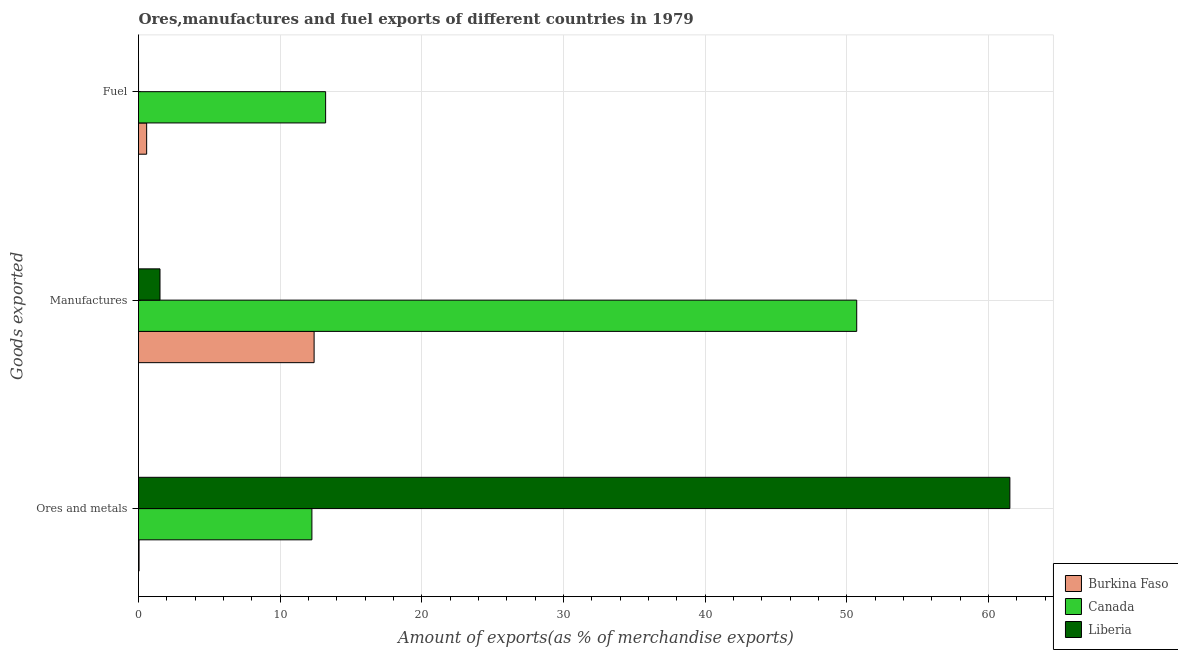How many different coloured bars are there?
Make the answer very short. 3. How many groups of bars are there?
Your answer should be very brief. 3. Are the number of bars per tick equal to the number of legend labels?
Provide a succinct answer. Yes. Are the number of bars on each tick of the Y-axis equal?
Offer a very short reply. Yes. How many bars are there on the 3rd tick from the top?
Your answer should be compact. 3. How many bars are there on the 1st tick from the bottom?
Your response must be concise. 3. What is the label of the 1st group of bars from the top?
Offer a very short reply. Fuel. What is the percentage of manufactures exports in Burkina Faso?
Offer a terse response. 12.4. Across all countries, what is the maximum percentage of fuel exports?
Make the answer very short. 13.21. Across all countries, what is the minimum percentage of fuel exports?
Keep it short and to the point. 0. In which country was the percentage of ores and metals exports minimum?
Your answer should be compact. Burkina Faso. What is the total percentage of ores and metals exports in the graph?
Give a very brief answer. 73.79. What is the difference between the percentage of ores and metals exports in Canada and that in Liberia?
Provide a short and direct response. -49.27. What is the difference between the percentage of manufactures exports in Burkina Faso and the percentage of fuel exports in Liberia?
Offer a very short reply. 12.4. What is the average percentage of manufactures exports per country?
Your response must be concise. 21.54. What is the difference between the percentage of manufactures exports and percentage of fuel exports in Canada?
Ensure brevity in your answer.  37.49. What is the ratio of the percentage of fuel exports in Liberia to that in Burkina Faso?
Make the answer very short. 0. Is the difference between the percentage of manufactures exports in Burkina Faso and Canada greater than the difference between the percentage of ores and metals exports in Burkina Faso and Canada?
Offer a terse response. No. What is the difference between the highest and the second highest percentage of ores and metals exports?
Your answer should be compact. 49.27. What is the difference between the highest and the lowest percentage of ores and metals exports?
Keep it short and to the point. 61.48. Is the sum of the percentage of ores and metals exports in Burkina Faso and Liberia greater than the maximum percentage of fuel exports across all countries?
Provide a succinct answer. Yes. What does the 3rd bar from the bottom in Fuel represents?
Offer a terse response. Liberia. How many bars are there?
Provide a succinct answer. 9. Are all the bars in the graph horizontal?
Provide a succinct answer. Yes. How many countries are there in the graph?
Your answer should be compact. 3. What is the difference between two consecutive major ticks on the X-axis?
Keep it short and to the point. 10. Does the graph contain grids?
Provide a short and direct response. Yes. Where does the legend appear in the graph?
Provide a short and direct response. Bottom right. How many legend labels are there?
Offer a terse response. 3. What is the title of the graph?
Your answer should be compact. Ores,manufactures and fuel exports of different countries in 1979. Does "Central Europe" appear as one of the legend labels in the graph?
Provide a short and direct response. No. What is the label or title of the X-axis?
Offer a terse response. Amount of exports(as % of merchandise exports). What is the label or title of the Y-axis?
Make the answer very short. Goods exported. What is the Amount of exports(as % of merchandise exports) of Burkina Faso in Ores and metals?
Your response must be concise. 0.04. What is the Amount of exports(as % of merchandise exports) in Canada in Ores and metals?
Keep it short and to the point. 12.24. What is the Amount of exports(as % of merchandise exports) of Liberia in Ores and metals?
Ensure brevity in your answer.  61.51. What is the Amount of exports(as % of merchandise exports) in Burkina Faso in Manufactures?
Ensure brevity in your answer.  12.4. What is the Amount of exports(as % of merchandise exports) in Canada in Manufactures?
Your response must be concise. 50.7. What is the Amount of exports(as % of merchandise exports) of Liberia in Manufactures?
Ensure brevity in your answer.  1.52. What is the Amount of exports(as % of merchandise exports) in Burkina Faso in Fuel?
Offer a very short reply. 0.58. What is the Amount of exports(as % of merchandise exports) in Canada in Fuel?
Provide a short and direct response. 13.21. What is the Amount of exports(as % of merchandise exports) of Liberia in Fuel?
Ensure brevity in your answer.  0. Across all Goods exported, what is the maximum Amount of exports(as % of merchandise exports) in Burkina Faso?
Make the answer very short. 12.4. Across all Goods exported, what is the maximum Amount of exports(as % of merchandise exports) of Canada?
Keep it short and to the point. 50.7. Across all Goods exported, what is the maximum Amount of exports(as % of merchandise exports) of Liberia?
Provide a short and direct response. 61.51. Across all Goods exported, what is the minimum Amount of exports(as % of merchandise exports) of Burkina Faso?
Give a very brief answer. 0.04. Across all Goods exported, what is the minimum Amount of exports(as % of merchandise exports) in Canada?
Provide a short and direct response. 12.24. Across all Goods exported, what is the minimum Amount of exports(as % of merchandise exports) of Liberia?
Your answer should be very brief. 0. What is the total Amount of exports(as % of merchandise exports) in Burkina Faso in the graph?
Your answer should be compact. 13.01. What is the total Amount of exports(as % of merchandise exports) in Canada in the graph?
Provide a succinct answer. 76.15. What is the total Amount of exports(as % of merchandise exports) of Liberia in the graph?
Provide a succinct answer. 63.03. What is the difference between the Amount of exports(as % of merchandise exports) in Burkina Faso in Ores and metals and that in Manufactures?
Ensure brevity in your answer.  -12.36. What is the difference between the Amount of exports(as % of merchandise exports) of Canada in Ores and metals and that in Manufactures?
Make the answer very short. -38.46. What is the difference between the Amount of exports(as % of merchandise exports) in Liberia in Ores and metals and that in Manufactures?
Keep it short and to the point. 60. What is the difference between the Amount of exports(as % of merchandise exports) in Burkina Faso in Ores and metals and that in Fuel?
Ensure brevity in your answer.  -0.54. What is the difference between the Amount of exports(as % of merchandise exports) in Canada in Ores and metals and that in Fuel?
Ensure brevity in your answer.  -0.97. What is the difference between the Amount of exports(as % of merchandise exports) of Liberia in Ores and metals and that in Fuel?
Provide a short and direct response. 61.51. What is the difference between the Amount of exports(as % of merchandise exports) in Burkina Faso in Manufactures and that in Fuel?
Your response must be concise. 11.82. What is the difference between the Amount of exports(as % of merchandise exports) of Canada in Manufactures and that in Fuel?
Offer a terse response. 37.49. What is the difference between the Amount of exports(as % of merchandise exports) in Liberia in Manufactures and that in Fuel?
Ensure brevity in your answer.  1.52. What is the difference between the Amount of exports(as % of merchandise exports) of Burkina Faso in Ores and metals and the Amount of exports(as % of merchandise exports) of Canada in Manufactures?
Provide a succinct answer. -50.66. What is the difference between the Amount of exports(as % of merchandise exports) of Burkina Faso in Ores and metals and the Amount of exports(as % of merchandise exports) of Liberia in Manufactures?
Provide a succinct answer. -1.48. What is the difference between the Amount of exports(as % of merchandise exports) in Canada in Ores and metals and the Amount of exports(as % of merchandise exports) in Liberia in Manufactures?
Your answer should be very brief. 10.72. What is the difference between the Amount of exports(as % of merchandise exports) in Burkina Faso in Ores and metals and the Amount of exports(as % of merchandise exports) in Canada in Fuel?
Make the answer very short. -13.17. What is the difference between the Amount of exports(as % of merchandise exports) in Burkina Faso in Ores and metals and the Amount of exports(as % of merchandise exports) in Liberia in Fuel?
Offer a terse response. 0.04. What is the difference between the Amount of exports(as % of merchandise exports) of Canada in Ores and metals and the Amount of exports(as % of merchandise exports) of Liberia in Fuel?
Provide a short and direct response. 12.24. What is the difference between the Amount of exports(as % of merchandise exports) of Burkina Faso in Manufactures and the Amount of exports(as % of merchandise exports) of Canada in Fuel?
Give a very brief answer. -0.81. What is the difference between the Amount of exports(as % of merchandise exports) of Burkina Faso in Manufactures and the Amount of exports(as % of merchandise exports) of Liberia in Fuel?
Provide a succinct answer. 12.4. What is the difference between the Amount of exports(as % of merchandise exports) in Canada in Manufactures and the Amount of exports(as % of merchandise exports) in Liberia in Fuel?
Your answer should be compact. 50.7. What is the average Amount of exports(as % of merchandise exports) in Burkina Faso per Goods exported?
Provide a short and direct response. 4.34. What is the average Amount of exports(as % of merchandise exports) in Canada per Goods exported?
Your answer should be very brief. 25.38. What is the average Amount of exports(as % of merchandise exports) of Liberia per Goods exported?
Give a very brief answer. 21.01. What is the difference between the Amount of exports(as % of merchandise exports) in Burkina Faso and Amount of exports(as % of merchandise exports) in Canada in Ores and metals?
Your answer should be very brief. -12.2. What is the difference between the Amount of exports(as % of merchandise exports) in Burkina Faso and Amount of exports(as % of merchandise exports) in Liberia in Ores and metals?
Your answer should be compact. -61.48. What is the difference between the Amount of exports(as % of merchandise exports) of Canada and Amount of exports(as % of merchandise exports) of Liberia in Ores and metals?
Offer a terse response. -49.27. What is the difference between the Amount of exports(as % of merchandise exports) in Burkina Faso and Amount of exports(as % of merchandise exports) in Canada in Manufactures?
Give a very brief answer. -38.31. What is the difference between the Amount of exports(as % of merchandise exports) in Burkina Faso and Amount of exports(as % of merchandise exports) in Liberia in Manufactures?
Make the answer very short. 10.88. What is the difference between the Amount of exports(as % of merchandise exports) in Canada and Amount of exports(as % of merchandise exports) in Liberia in Manufactures?
Your answer should be very brief. 49.19. What is the difference between the Amount of exports(as % of merchandise exports) of Burkina Faso and Amount of exports(as % of merchandise exports) of Canada in Fuel?
Provide a succinct answer. -12.63. What is the difference between the Amount of exports(as % of merchandise exports) in Burkina Faso and Amount of exports(as % of merchandise exports) in Liberia in Fuel?
Your response must be concise. 0.57. What is the difference between the Amount of exports(as % of merchandise exports) in Canada and Amount of exports(as % of merchandise exports) in Liberia in Fuel?
Keep it short and to the point. 13.21. What is the ratio of the Amount of exports(as % of merchandise exports) of Burkina Faso in Ores and metals to that in Manufactures?
Make the answer very short. 0. What is the ratio of the Amount of exports(as % of merchandise exports) in Canada in Ores and metals to that in Manufactures?
Keep it short and to the point. 0.24. What is the ratio of the Amount of exports(as % of merchandise exports) in Liberia in Ores and metals to that in Manufactures?
Keep it short and to the point. 40.54. What is the ratio of the Amount of exports(as % of merchandise exports) of Burkina Faso in Ores and metals to that in Fuel?
Offer a very short reply. 0.07. What is the ratio of the Amount of exports(as % of merchandise exports) in Canada in Ores and metals to that in Fuel?
Keep it short and to the point. 0.93. What is the ratio of the Amount of exports(as % of merchandise exports) in Liberia in Ores and metals to that in Fuel?
Give a very brief answer. 3.42e+04. What is the ratio of the Amount of exports(as % of merchandise exports) in Burkina Faso in Manufactures to that in Fuel?
Your response must be concise. 21.53. What is the ratio of the Amount of exports(as % of merchandise exports) in Canada in Manufactures to that in Fuel?
Give a very brief answer. 3.84. What is the ratio of the Amount of exports(as % of merchandise exports) of Liberia in Manufactures to that in Fuel?
Ensure brevity in your answer.  842.58. What is the difference between the highest and the second highest Amount of exports(as % of merchandise exports) in Burkina Faso?
Make the answer very short. 11.82. What is the difference between the highest and the second highest Amount of exports(as % of merchandise exports) of Canada?
Your answer should be compact. 37.49. What is the difference between the highest and the second highest Amount of exports(as % of merchandise exports) of Liberia?
Provide a short and direct response. 60. What is the difference between the highest and the lowest Amount of exports(as % of merchandise exports) of Burkina Faso?
Make the answer very short. 12.36. What is the difference between the highest and the lowest Amount of exports(as % of merchandise exports) in Canada?
Your response must be concise. 38.46. What is the difference between the highest and the lowest Amount of exports(as % of merchandise exports) of Liberia?
Offer a terse response. 61.51. 